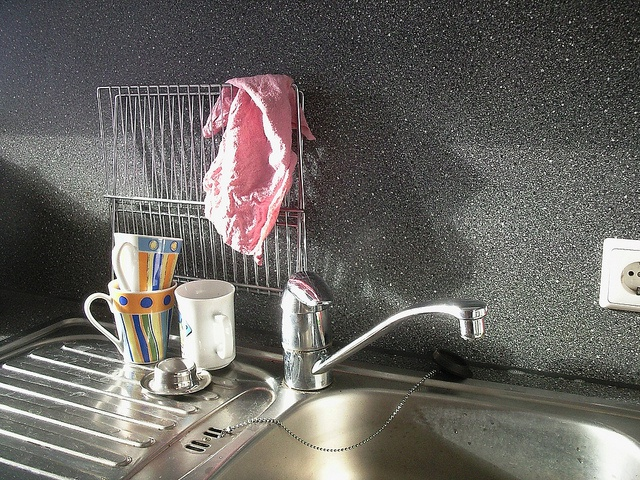Describe the objects in this image and their specific colors. I can see sink in black, gray, and ivory tones, cup in black, ivory, gray, and tan tones, cup in black, ivory, darkgray, and lightgray tones, and cup in black, white, darkgray, and tan tones in this image. 